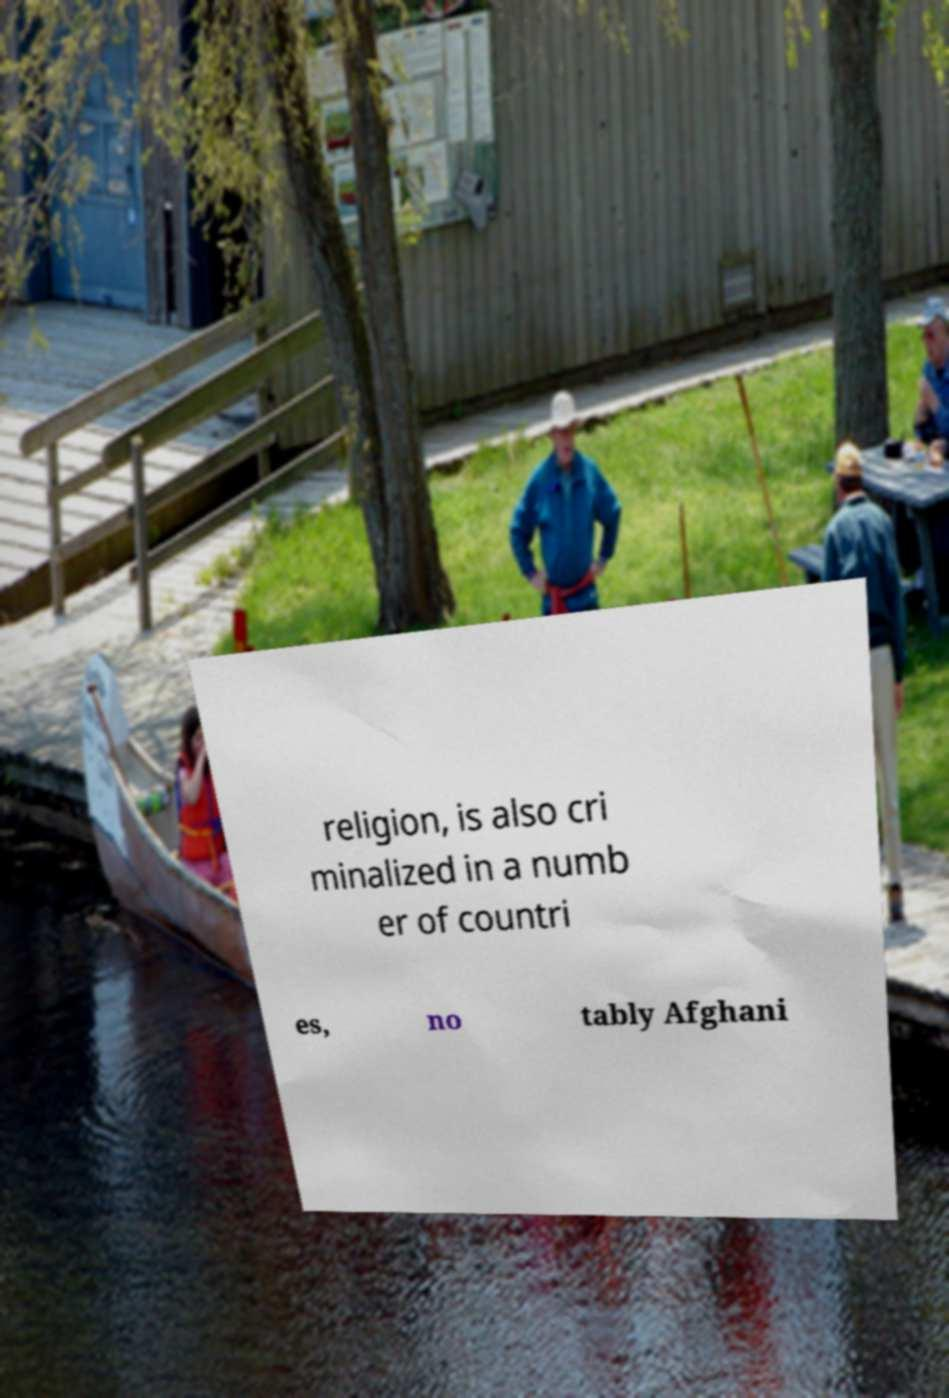Can you read and provide the text displayed in the image?This photo seems to have some interesting text. Can you extract and type it out for me? religion, is also cri minalized in a numb er of countri es, no tably Afghani 